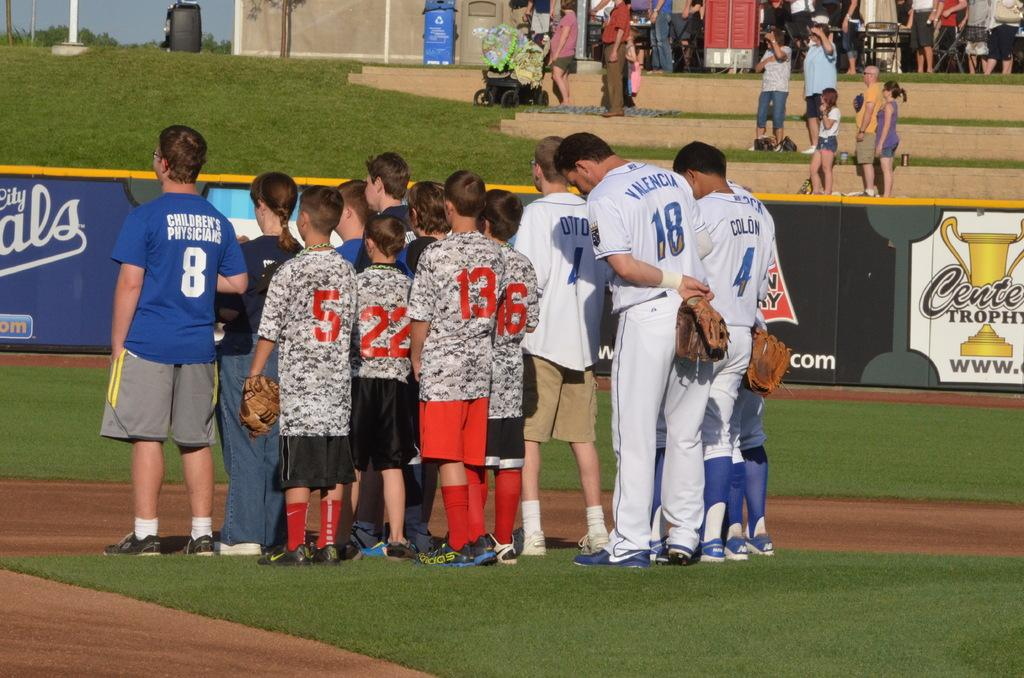<image>
Describe the image concisely. Group of people in a huddle with number 18 listening on. 